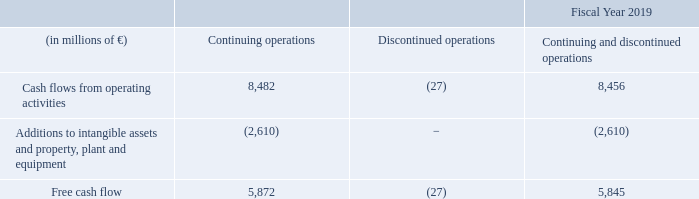Free cash flow
The Free cash flow for the Industrial Businesses amounted to €8,000 millions, resulting in a cash conversation rate of 0.89.
Beginning with fiscal 2020, Siemens adopts IFRS 16, Leases, applying
the modified retrospective approach as described in more detail in NOTE 2 in B.6 NOTES TO CONSOLIDATED FINANCIAL STATEMENTS. As a result, the shift of lease payments from cash flows from operating activities to cash flows from financing activities will have a positive effect on Free cash flow.
With our ability to generate positive operating cash flows, our total liquidity (defined as cash and cash equivalents plus current interest-bearing debt securities) of €13.7 billion, our unused lines of credit, and our credit ratings at year-end, we believe that we have sufficient flexibility to fund our capital requirements. Also in our opinion, our operating net working capital is sufficient for our present requirements.
What was the Free cash flow for the Industrial Businesses? €8,000 millions. What is the source for capital funding requirement? With our ability to generate positive operating cash flows, our total liquidity (defined as cash and cash equivalents plus current interest-bearing debt securities) of €13.7 billion, our unused lines of credit, and our credit ratings at year-end, we believe that we have sufficient flexibility to fund our capital requirements. What is the cash conversion rate? 0.89. What was the average cash flow from operating activities from continuing and discontinued operations?
Answer scale should be: million. (8,482 - 27) / 2
Answer: 4227.5. What is the increase / (decrease) of continuing operations compared to the discontinued operations for Additions to intangible assets and property, plant and equipment?
Answer scale should be: million. (2,610 - 0)
Answer: 2610. What percentage increase / (decrease) is Free cash flow in continuing operations compared to discontinued operations?
Answer scale should be: percent. - (5,872 / -27 - 1)
Answer: 218.48. 